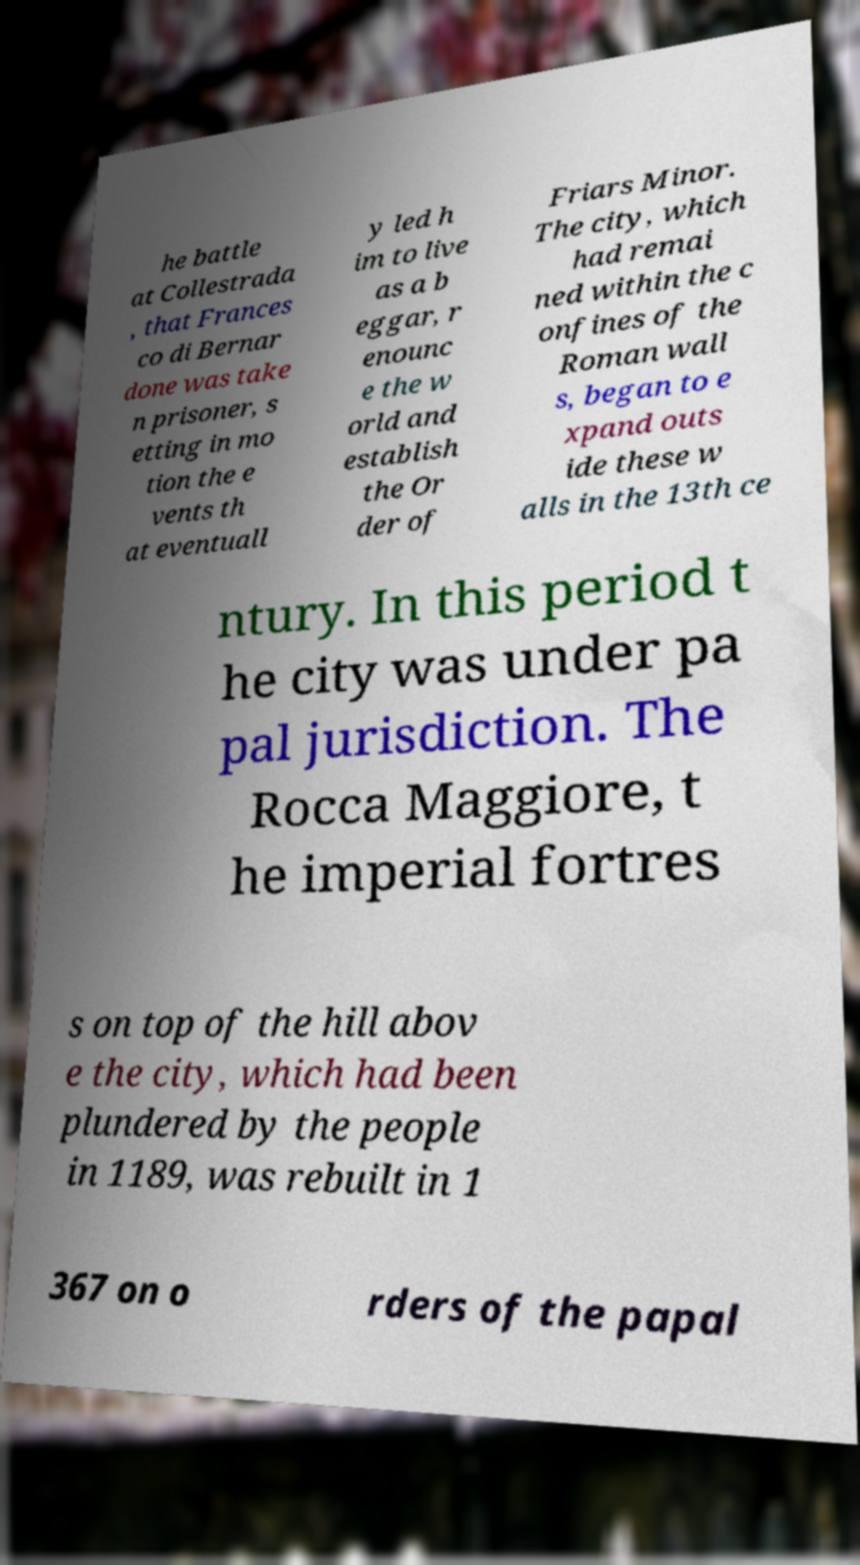What messages or text are displayed in this image? I need them in a readable, typed format. he battle at Collestrada , that Frances co di Bernar done was take n prisoner, s etting in mo tion the e vents th at eventuall y led h im to live as a b eggar, r enounc e the w orld and establish the Or der of Friars Minor. The city, which had remai ned within the c onfines of the Roman wall s, began to e xpand outs ide these w alls in the 13th ce ntury. In this period t he city was under pa pal jurisdiction. The Rocca Maggiore, t he imperial fortres s on top of the hill abov e the city, which had been plundered by the people in 1189, was rebuilt in 1 367 on o rders of the papal 